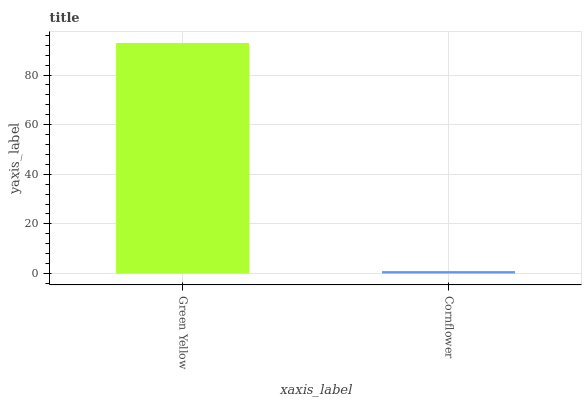Is Cornflower the maximum?
Answer yes or no. No. Is Green Yellow greater than Cornflower?
Answer yes or no. Yes. Is Cornflower less than Green Yellow?
Answer yes or no. Yes. Is Cornflower greater than Green Yellow?
Answer yes or no. No. Is Green Yellow less than Cornflower?
Answer yes or no. No. Is Green Yellow the high median?
Answer yes or no. Yes. Is Cornflower the low median?
Answer yes or no. Yes. Is Cornflower the high median?
Answer yes or no. No. Is Green Yellow the low median?
Answer yes or no. No. 